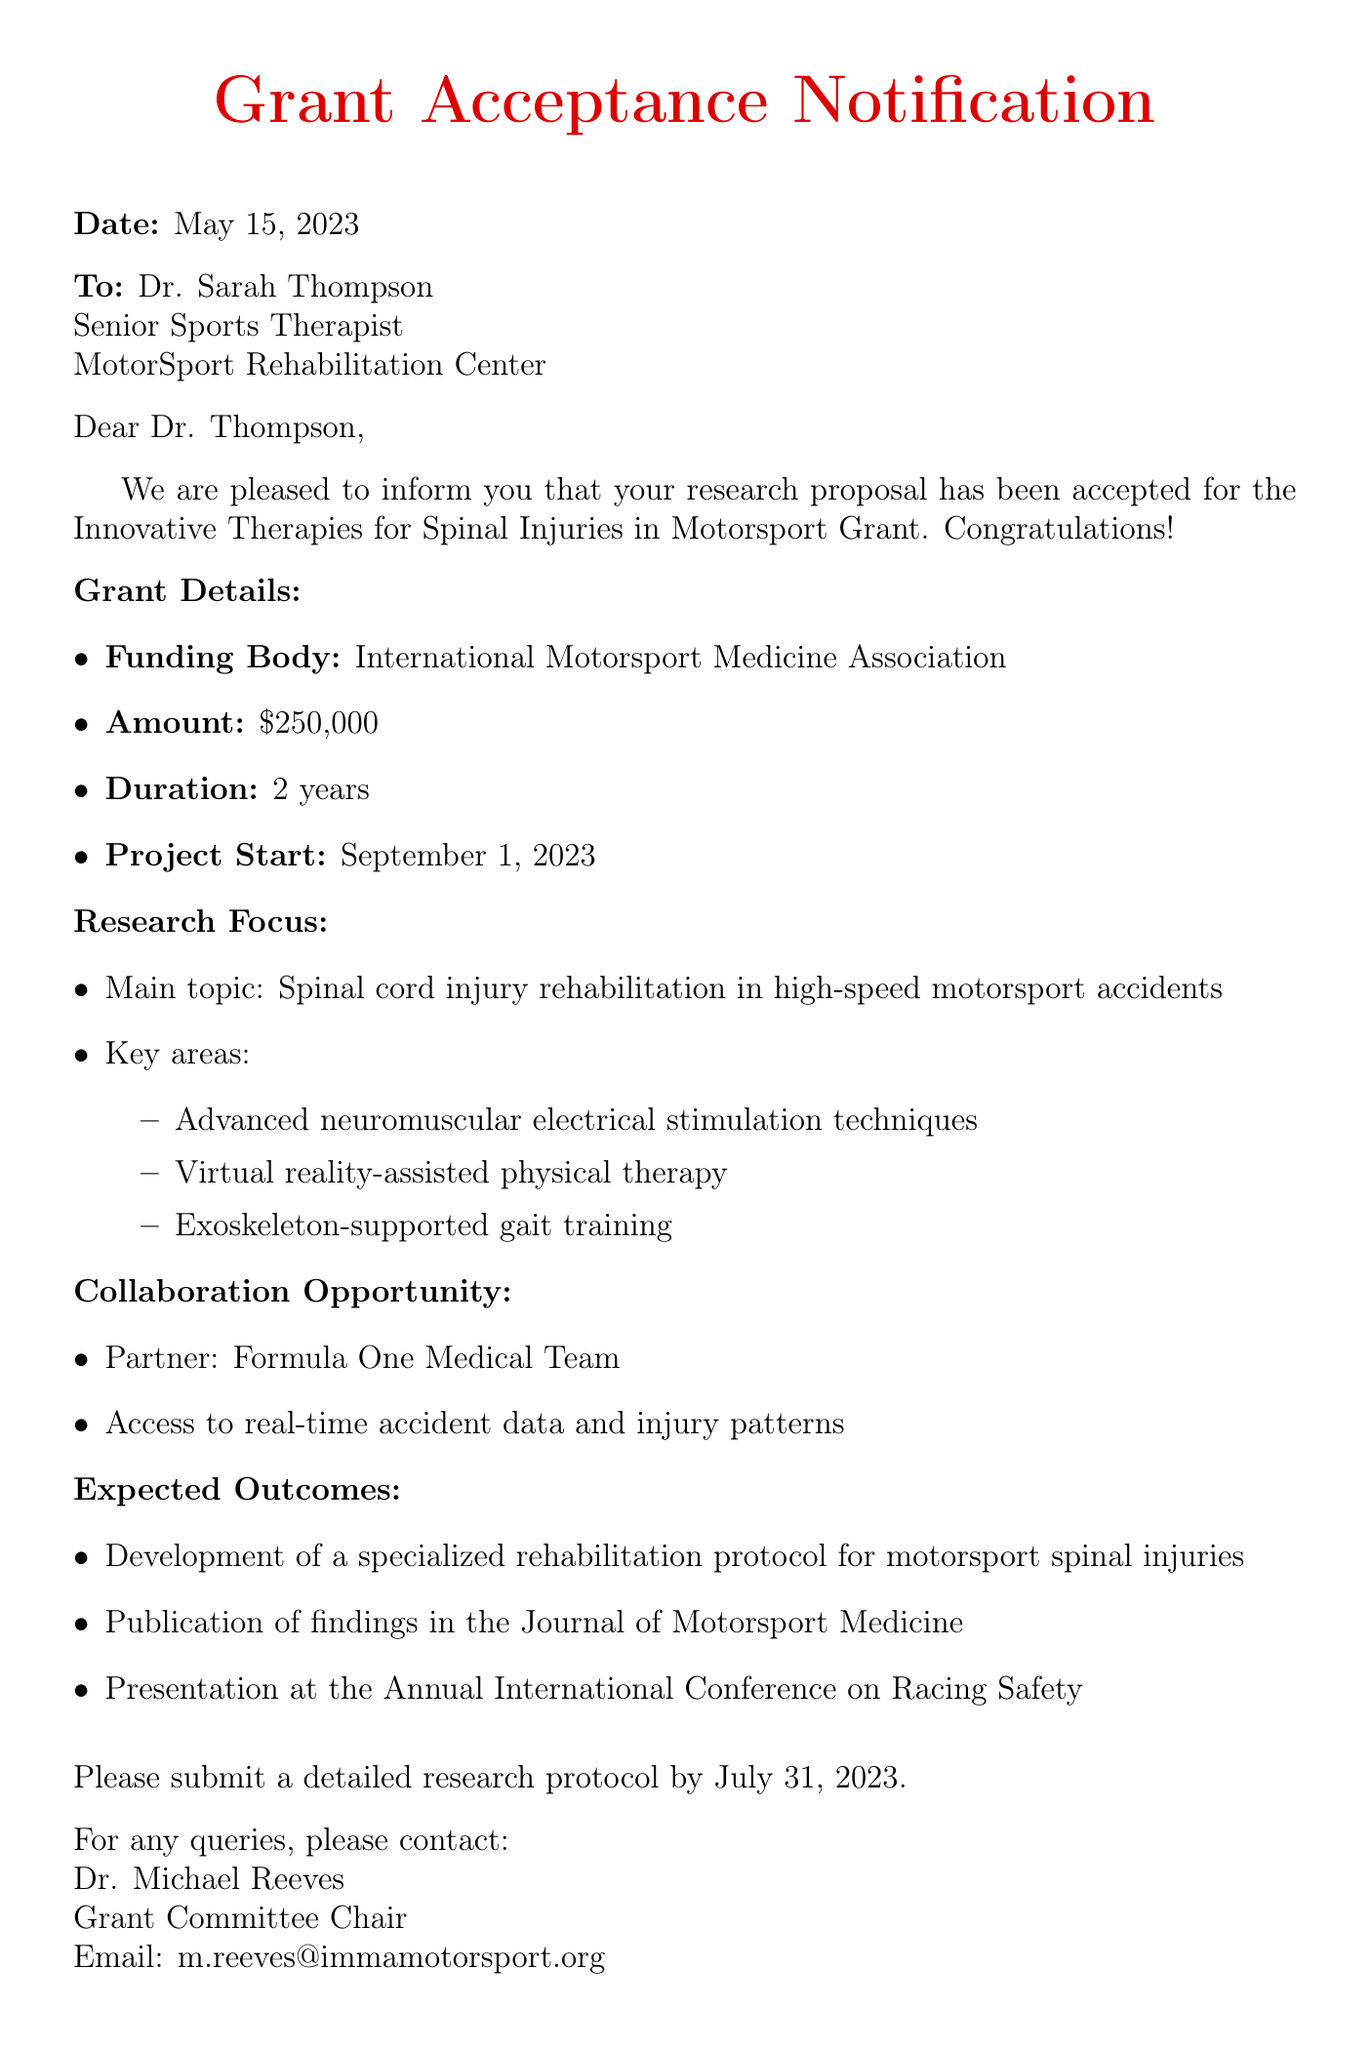What is the name of the grant? The grant is specifically named in the document, which is "Innovative Therapies for Spinal Injuries in Motorsport Grant."
Answer: Innovative Therapies for Spinal Injuries in Motorsport Grant Who is the recipient of the notification? The document addresses the notification directly to Dr. Sarah Thompson, indicating she is the recipient.
Answer: Dr. Sarah Thompson What is the total funding amount awarded? The document states the total funding amount provided for the grant is $250,000.
Answer: $250,000 When is the project start date? The project start date is specified in the document as September 1, 2023.
Answer: September 1, 2023 What must be submitted by July 31, 2023? The document details that a "detailed research protocol" must be submitted by this date.
Answer: Detailed research protocol Which institution is providing collaboration opportunities? The document mentions the "Formula One Medical Team" as the partner institution for collaboration.
Answer: Formula One Medical Team What is one expected outcome of the research? The document lists several expected outcomes, one of which is "Development of a specialized rehabilitation protocol for motorsport spinal injuries."
Answer: Development of a specialized rehabilitation protocol for motorsport spinal injuries What is the email address for the contact person? The document provides contact details for Dr. Michael Reeves, including the email address listed.
Answer: m.reeves@immamotorsport.org 